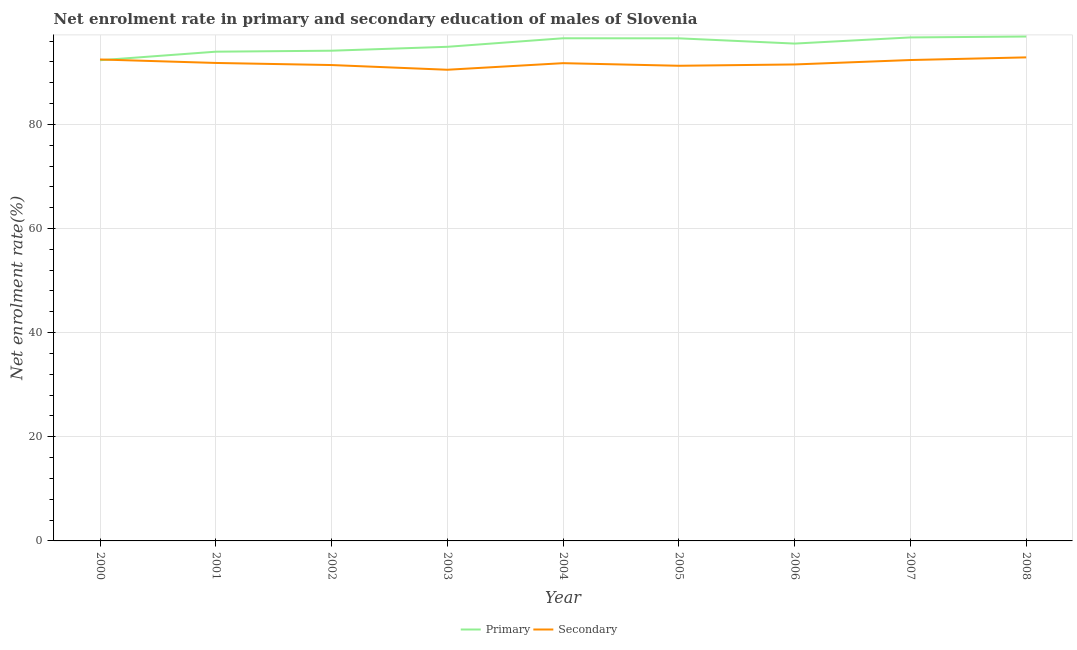How many different coloured lines are there?
Make the answer very short. 2. Does the line corresponding to enrollment rate in secondary education intersect with the line corresponding to enrollment rate in primary education?
Provide a short and direct response. Yes. What is the enrollment rate in primary education in 2008?
Give a very brief answer. 96.87. Across all years, what is the maximum enrollment rate in primary education?
Provide a short and direct response. 96.87. Across all years, what is the minimum enrollment rate in secondary education?
Keep it short and to the point. 90.49. In which year was the enrollment rate in primary education maximum?
Your answer should be compact. 2008. What is the total enrollment rate in primary education in the graph?
Give a very brief answer. 857.44. What is the difference between the enrollment rate in secondary education in 2002 and that in 2008?
Your answer should be very brief. -1.47. What is the difference between the enrollment rate in secondary education in 2002 and the enrollment rate in primary education in 2000?
Your answer should be compact. -0.92. What is the average enrollment rate in primary education per year?
Give a very brief answer. 95.27. In the year 2004, what is the difference between the enrollment rate in secondary education and enrollment rate in primary education?
Keep it short and to the point. -4.78. In how many years, is the enrollment rate in secondary education greater than 76 %?
Ensure brevity in your answer.  9. What is the ratio of the enrollment rate in secondary education in 2001 to that in 2004?
Provide a succinct answer. 1. What is the difference between the highest and the second highest enrollment rate in secondary education?
Make the answer very short. 0.4. What is the difference between the highest and the lowest enrollment rate in primary education?
Your response must be concise. 4.55. In how many years, is the enrollment rate in secondary education greater than the average enrollment rate in secondary education taken over all years?
Keep it short and to the point. 4. Is the enrollment rate in secondary education strictly greater than the enrollment rate in primary education over the years?
Your response must be concise. No. Is the enrollment rate in secondary education strictly less than the enrollment rate in primary education over the years?
Provide a short and direct response. No. How many years are there in the graph?
Your answer should be compact. 9. Does the graph contain grids?
Make the answer very short. Yes. How many legend labels are there?
Your answer should be very brief. 2. How are the legend labels stacked?
Provide a short and direct response. Horizontal. What is the title of the graph?
Your answer should be compact. Net enrolment rate in primary and secondary education of males of Slovenia. What is the label or title of the Y-axis?
Provide a succinct answer. Net enrolment rate(%). What is the Net enrolment rate(%) in Primary in 2000?
Provide a succinct answer. 92.31. What is the Net enrolment rate(%) in Secondary in 2000?
Keep it short and to the point. 92.46. What is the Net enrolment rate(%) in Primary in 2001?
Provide a short and direct response. 93.96. What is the Net enrolment rate(%) of Secondary in 2001?
Your answer should be compact. 91.79. What is the Net enrolment rate(%) in Primary in 2002?
Provide a short and direct response. 94.14. What is the Net enrolment rate(%) in Secondary in 2002?
Keep it short and to the point. 91.39. What is the Net enrolment rate(%) of Primary in 2003?
Ensure brevity in your answer.  94.89. What is the Net enrolment rate(%) of Secondary in 2003?
Offer a very short reply. 90.49. What is the Net enrolment rate(%) of Primary in 2004?
Your answer should be very brief. 96.53. What is the Net enrolment rate(%) in Secondary in 2004?
Offer a very short reply. 91.75. What is the Net enrolment rate(%) of Primary in 2005?
Keep it short and to the point. 96.52. What is the Net enrolment rate(%) in Secondary in 2005?
Offer a terse response. 91.25. What is the Net enrolment rate(%) in Primary in 2006?
Provide a succinct answer. 95.51. What is the Net enrolment rate(%) of Secondary in 2006?
Your response must be concise. 91.51. What is the Net enrolment rate(%) of Primary in 2007?
Your answer should be compact. 96.7. What is the Net enrolment rate(%) of Secondary in 2007?
Give a very brief answer. 92.35. What is the Net enrolment rate(%) of Primary in 2008?
Keep it short and to the point. 96.87. What is the Net enrolment rate(%) in Secondary in 2008?
Your answer should be compact. 92.86. Across all years, what is the maximum Net enrolment rate(%) of Primary?
Provide a succinct answer. 96.87. Across all years, what is the maximum Net enrolment rate(%) in Secondary?
Make the answer very short. 92.86. Across all years, what is the minimum Net enrolment rate(%) in Primary?
Your answer should be very brief. 92.31. Across all years, what is the minimum Net enrolment rate(%) of Secondary?
Offer a very short reply. 90.49. What is the total Net enrolment rate(%) in Primary in the graph?
Offer a very short reply. 857.44. What is the total Net enrolment rate(%) in Secondary in the graph?
Keep it short and to the point. 825.86. What is the difference between the Net enrolment rate(%) in Primary in 2000 and that in 2001?
Keep it short and to the point. -1.64. What is the difference between the Net enrolment rate(%) of Secondary in 2000 and that in 2001?
Your answer should be very brief. 0.67. What is the difference between the Net enrolment rate(%) in Primary in 2000 and that in 2002?
Your answer should be very brief. -1.83. What is the difference between the Net enrolment rate(%) in Secondary in 2000 and that in 2002?
Keep it short and to the point. 1.07. What is the difference between the Net enrolment rate(%) in Primary in 2000 and that in 2003?
Keep it short and to the point. -2.58. What is the difference between the Net enrolment rate(%) of Secondary in 2000 and that in 2003?
Provide a short and direct response. 1.98. What is the difference between the Net enrolment rate(%) in Primary in 2000 and that in 2004?
Keep it short and to the point. -4.22. What is the difference between the Net enrolment rate(%) in Secondary in 2000 and that in 2004?
Ensure brevity in your answer.  0.71. What is the difference between the Net enrolment rate(%) of Primary in 2000 and that in 2005?
Offer a very short reply. -4.21. What is the difference between the Net enrolment rate(%) in Secondary in 2000 and that in 2005?
Your answer should be compact. 1.21. What is the difference between the Net enrolment rate(%) in Primary in 2000 and that in 2006?
Give a very brief answer. -3.2. What is the difference between the Net enrolment rate(%) in Secondary in 2000 and that in 2006?
Offer a terse response. 0.96. What is the difference between the Net enrolment rate(%) of Primary in 2000 and that in 2007?
Your response must be concise. -4.38. What is the difference between the Net enrolment rate(%) in Secondary in 2000 and that in 2007?
Ensure brevity in your answer.  0.11. What is the difference between the Net enrolment rate(%) in Primary in 2000 and that in 2008?
Provide a succinct answer. -4.55. What is the difference between the Net enrolment rate(%) of Secondary in 2000 and that in 2008?
Offer a terse response. -0.4. What is the difference between the Net enrolment rate(%) of Primary in 2001 and that in 2002?
Give a very brief answer. -0.19. What is the difference between the Net enrolment rate(%) in Secondary in 2001 and that in 2002?
Your answer should be very brief. 0.4. What is the difference between the Net enrolment rate(%) of Primary in 2001 and that in 2003?
Your answer should be compact. -0.94. What is the difference between the Net enrolment rate(%) of Secondary in 2001 and that in 2003?
Provide a short and direct response. 1.31. What is the difference between the Net enrolment rate(%) in Primary in 2001 and that in 2004?
Offer a terse response. -2.58. What is the difference between the Net enrolment rate(%) in Secondary in 2001 and that in 2004?
Offer a terse response. 0.04. What is the difference between the Net enrolment rate(%) of Primary in 2001 and that in 2005?
Ensure brevity in your answer.  -2.57. What is the difference between the Net enrolment rate(%) in Secondary in 2001 and that in 2005?
Provide a short and direct response. 0.54. What is the difference between the Net enrolment rate(%) in Primary in 2001 and that in 2006?
Offer a terse response. -1.56. What is the difference between the Net enrolment rate(%) of Secondary in 2001 and that in 2006?
Provide a succinct answer. 0.29. What is the difference between the Net enrolment rate(%) in Primary in 2001 and that in 2007?
Provide a succinct answer. -2.74. What is the difference between the Net enrolment rate(%) of Secondary in 2001 and that in 2007?
Make the answer very short. -0.56. What is the difference between the Net enrolment rate(%) of Primary in 2001 and that in 2008?
Your answer should be very brief. -2.91. What is the difference between the Net enrolment rate(%) of Secondary in 2001 and that in 2008?
Make the answer very short. -1.07. What is the difference between the Net enrolment rate(%) in Primary in 2002 and that in 2003?
Provide a short and direct response. -0.75. What is the difference between the Net enrolment rate(%) in Secondary in 2002 and that in 2003?
Offer a very short reply. 0.9. What is the difference between the Net enrolment rate(%) of Primary in 2002 and that in 2004?
Offer a terse response. -2.39. What is the difference between the Net enrolment rate(%) in Secondary in 2002 and that in 2004?
Your answer should be compact. -0.36. What is the difference between the Net enrolment rate(%) of Primary in 2002 and that in 2005?
Provide a succinct answer. -2.38. What is the difference between the Net enrolment rate(%) of Secondary in 2002 and that in 2005?
Give a very brief answer. 0.14. What is the difference between the Net enrolment rate(%) in Primary in 2002 and that in 2006?
Your response must be concise. -1.37. What is the difference between the Net enrolment rate(%) of Secondary in 2002 and that in 2006?
Provide a short and direct response. -0.12. What is the difference between the Net enrolment rate(%) in Primary in 2002 and that in 2007?
Make the answer very short. -2.55. What is the difference between the Net enrolment rate(%) in Secondary in 2002 and that in 2007?
Your answer should be compact. -0.96. What is the difference between the Net enrolment rate(%) in Primary in 2002 and that in 2008?
Offer a very short reply. -2.72. What is the difference between the Net enrolment rate(%) in Secondary in 2002 and that in 2008?
Your answer should be compact. -1.47. What is the difference between the Net enrolment rate(%) of Primary in 2003 and that in 2004?
Make the answer very short. -1.64. What is the difference between the Net enrolment rate(%) of Secondary in 2003 and that in 2004?
Offer a terse response. -1.27. What is the difference between the Net enrolment rate(%) of Primary in 2003 and that in 2005?
Offer a terse response. -1.63. What is the difference between the Net enrolment rate(%) in Secondary in 2003 and that in 2005?
Offer a very short reply. -0.77. What is the difference between the Net enrolment rate(%) in Primary in 2003 and that in 2006?
Offer a very short reply. -0.62. What is the difference between the Net enrolment rate(%) in Secondary in 2003 and that in 2006?
Offer a very short reply. -1.02. What is the difference between the Net enrolment rate(%) in Primary in 2003 and that in 2007?
Provide a succinct answer. -1.8. What is the difference between the Net enrolment rate(%) of Secondary in 2003 and that in 2007?
Offer a terse response. -1.87. What is the difference between the Net enrolment rate(%) in Primary in 2003 and that in 2008?
Your response must be concise. -1.97. What is the difference between the Net enrolment rate(%) in Secondary in 2003 and that in 2008?
Your answer should be compact. -2.38. What is the difference between the Net enrolment rate(%) of Primary in 2004 and that in 2005?
Your answer should be compact. 0.01. What is the difference between the Net enrolment rate(%) of Secondary in 2004 and that in 2005?
Keep it short and to the point. 0.5. What is the difference between the Net enrolment rate(%) in Primary in 2004 and that in 2006?
Give a very brief answer. 1.02. What is the difference between the Net enrolment rate(%) in Secondary in 2004 and that in 2006?
Your answer should be compact. 0.25. What is the difference between the Net enrolment rate(%) of Primary in 2004 and that in 2007?
Your answer should be very brief. -0.16. What is the difference between the Net enrolment rate(%) in Secondary in 2004 and that in 2007?
Ensure brevity in your answer.  -0.6. What is the difference between the Net enrolment rate(%) of Primary in 2004 and that in 2008?
Give a very brief answer. -0.33. What is the difference between the Net enrolment rate(%) in Secondary in 2004 and that in 2008?
Provide a short and direct response. -1.11. What is the difference between the Net enrolment rate(%) of Primary in 2005 and that in 2006?
Provide a short and direct response. 1.01. What is the difference between the Net enrolment rate(%) in Secondary in 2005 and that in 2006?
Provide a succinct answer. -0.25. What is the difference between the Net enrolment rate(%) of Primary in 2005 and that in 2007?
Keep it short and to the point. -0.17. What is the difference between the Net enrolment rate(%) in Secondary in 2005 and that in 2007?
Make the answer very short. -1.1. What is the difference between the Net enrolment rate(%) in Primary in 2005 and that in 2008?
Your answer should be very brief. -0.34. What is the difference between the Net enrolment rate(%) in Secondary in 2005 and that in 2008?
Provide a short and direct response. -1.61. What is the difference between the Net enrolment rate(%) in Primary in 2006 and that in 2007?
Your response must be concise. -1.18. What is the difference between the Net enrolment rate(%) of Secondary in 2006 and that in 2007?
Make the answer very short. -0.85. What is the difference between the Net enrolment rate(%) in Primary in 2006 and that in 2008?
Provide a succinct answer. -1.35. What is the difference between the Net enrolment rate(%) in Secondary in 2006 and that in 2008?
Your answer should be compact. -1.36. What is the difference between the Net enrolment rate(%) of Primary in 2007 and that in 2008?
Your answer should be very brief. -0.17. What is the difference between the Net enrolment rate(%) in Secondary in 2007 and that in 2008?
Offer a very short reply. -0.51. What is the difference between the Net enrolment rate(%) of Primary in 2000 and the Net enrolment rate(%) of Secondary in 2001?
Your answer should be compact. 0.52. What is the difference between the Net enrolment rate(%) of Primary in 2000 and the Net enrolment rate(%) of Secondary in 2002?
Provide a short and direct response. 0.92. What is the difference between the Net enrolment rate(%) of Primary in 2000 and the Net enrolment rate(%) of Secondary in 2003?
Your answer should be compact. 1.83. What is the difference between the Net enrolment rate(%) in Primary in 2000 and the Net enrolment rate(%) in Secondary in 2004?
Offer a very short reply. 0.56. What is the difference between the Net enrolment rate(%) in Primary in 2000 and the Net enrolment rate(%) in Secondary in 2005?
Offer a very short reply. 1.06. What is the difference between the Net enrolment rate(%) in Primary in 2000 and the Net enrolment rate(%) in Secondary in 2006?
Your response must be concise. 0.81. What is the difference between the Net enrolment rate(%) of Primary in 2000 and the Net enrolment rate(%) of Secondary in 2007?
Your response must be concise. -0.04. What is the difference between the Net enrolment rate(%) of Primary in 2000 and the Net enrolment rate(%) of Secondary in 2008?
Provide a succinct answer. -0.55. What is the difference between the Net enrolment rate(%) in Primary in 2001 and the Net enrolment rate(%) in Secondary in 2002?
Ensure brevity in your answer.  2.56. What is the difference between the Net enrolment rate(%) in Primary in 2001 and the Net enrolment rate(%) in Secondary in 2003?
Provide a short and direct response. 3.47. What is the difference between the Net enrolment rate(%) of Primary in 2001 and the Net enrolment rate(%) of Secondary in 2004?
Keep it short and to the point. 2.2. What is the difference between the Net enrolment rate(%) of Primary in 2001 and the Net enrolment rate(%) of Secondary in 2005?
Offer a terse response. 2.7. What is the difference between the Net enrolment rate(%) in Primary in 2001 and the Net enrolment rate(%) in Secondary in 2006?
Offer a terse response. 2.45. What is the difference between the Net enrolment rate(%) of Primary in 2001 and the Net enrolment rate(%) of Secondary in 2007?
Ensure brevity in your answer.  1.6. What is the difference between the Net enrolment rate(%) in Primary in 2001 and the Net enrolment rate(%) in Secondary in 2008?
Keep it short and to the point. 1.09. What is the difference between the Net enrolment rate(%) of Primary in 2002 and the Net enrolment rate(%) of Secondary in 2003?
Your response must be concise. 3.66. What is the difference between the Net enrolment rate(%) in Primary in 2002 and the Net enrolment rate(%) in Secondary in 2004?
Your response must be concise. 2.39. What is the difference between the Net enrolment rate(%) of Primary in 2002 and the Net enrolment rate(%) of Secondary in 2005?
Provide a succinct answer. 2.89. What is the difference between the Net enrolment rate(%) of Primary in 2002 and the Net enrolment rate(%) of Secondary in 2006?
Provide a succinct answer. 2.64. What is the difference between the Net enrolment rate(%) in Primary in 2002 and the Net enrolment rate(%) in Secondary in 2007?
Provide a succinct answer. 1.79. What is the difference between the Net enrolment rate(%) of Primary in 2002 and the Net enrolment rate(%) of Secondary in 2008?
Keep it short and to the point. 1.28. What is the difference between the Net enrolment rate(%) of Primary in 2003 and the Net enrolment rate(%) of Secondary in 2004?
Provide a short and direct response. 3.14. What is the difference between the Net enrolment rate(%) in Primary in 2003 and the Net enrolment rate(%) in Secondary in 2005?
Your response must be concise. 3.64. What is the difference between the Net enrolment rate(%) in Primary in 2003 and the Net enrolment rate(%) in Secondary in 2006?
Your answer should be compact. 3.39. What is the difference between the Net enrolment rate(%) in Primary in 2003 and the Net enrolment rate(%) in Secondary in 2007?
Keep it short and to the point. 2.54. What is the difference between the Net enrolment rate(%) of Primary in 2003 and the Net enrolment rate(%) of Secondary in 2008?
Your answer should be compact. 2.03. What is the difference between the Net enrolment rate(%) in Primary in 2004 and the Net enrolment rate(%) in Secondary in 2005?
Offer a very short reply. 5.28. What is the difference between the Net enrolment rate(%) of Primary in 2004 and the Net enrolment rate(%) of Secondary in 2006?
Make the answer very short. 5.03. What is the difference between the Net enrolment rate(%) of Primary in 2004 and the Net enrolment rate(%) of Secondary in 2007?
Provide a short and direct response. 4.18. What is the difference between the Net enrolment rate(%) in Primary in 2004 and the Net enrolment rate(%) in Secondary in 2008?
Keep it short and to the point. 3.67. What is the difference between the Net enrolment rate(%) in Primary in 2005 and the Net enrolment rate(%) in Secondary in 2006?
Give a very brief answer. 5.02. What is the difference between the Net enrolment rate(%) of Primary in 2005 and the Net enrolment rate(%) of Secondary in 2007?
Offer a terse response. 4.17. What is the difference between the Net enrolment rate(%) in Primary in 2005 and the Net enrolment rate(%) in Secondary in 2008?
Your answer should be compact. 3.66. What is the difference between the Net enrolment rate(%) of Primary in 2006 and the Net enrolment rate(%) of Secondary in 2007?
Provide a short and direct response. 3.16. What is the difference between the Net enrolment rate(%) of Primary in 2006 and the Net enrolment rate(%) of Secondary in 2008?
Keep it short and to the point. 2.65. What is the difference between the Net enrolment rate(%) in Primary in 2007 and the Net enrolment rate(%) in Secondary in 2008?
Provide a short and direct response. 3.83. What is the average Net enrolment rate(%) of Primary per year?
Offer a very short reply. 95.27. What is the average Net enrolment rate(%) in Secondary per year?
Keep it short and to the point. 91.76. In the year 2000, what is the difference between the Net enrolment rate(%) in Primary and Net enrolment rate(%) in Secondary?
Your answer should be very brief. -0.15. In the year 2001, what is the difference between the Net enrolment rate(%) of Primary and Net enrolment rate(%) of Secondary?
Give a very brief answer. 2.16. In the year 2002, what is the difference between the Net enrolment rate(%) in Primary and Net enrolment rate(%) in Secondary?
Your answer should be very brief. 2.75. In the year 2003, what is the difference between the Net enrolment rate(%) in Primary and Net enrolment rate(%) in Secondary?
Ensure brevity in your answer.  4.41. In the year 2004, what is the difference between the Net enrolment rate(%) of Primary and Net enrolment rate(%) of Secondary?
Your answer should be compact. 4.78. In the year 2005, what is the difference between the Net enrolment rate(%) of Primary and Net enrolment rate(%) of Secondary?
Keep it short and to the point. 5.27. In the year 2006, what is the difference between the Net enrolment rate(%) in Primary and Net enrolment rate(%) in Secondary?
Ensure brevity in your answer.  4.01. In the year 2007, what is the difference between the Net enrolment rate(%) in Primary and Net enrolment rate(%) in Secondary?
Ensure brevity in your answer.  4.34. In the year 2008, what is the difference between the Net enrolment rate(%) in Primary and Net enrolment rate(%) in Secondary?
Provide a short and direct response. 4. What is the ratio of the Net enrolment rate(%) of Primary in 2000 to that in 2001?
Your answer should be very brief. 0.98. What is the ratio of the Net enrolment rate(%) of Secondary in 2000 to that in 2001?
Ensure brevity in your answer.  1.01. What is the ratio of the Net enrolment rate(%) of Primary in 2000 to that in 2002?
Make the answer very short. 0.98. What is the ratio of the Net enrolment rate(%) in Secondary in 2000 to that in 2002?
Your answer should be very brief. 1.01. What is the ratio of the Net enrolment rate(%) in Primary in 2000 to that in 2003?
Keep it short and to the point. 0.97. What is the ratio of the Net enrolment rate(%) in Secondary in 2000 to that in 2003?
Give a very brief answer. 1.02. What is the ratio of the Net enrolment rate(%) in Primary in 2000 to that in 2004?
Give a very brief answer. 0.96. What is the ratio of the Net enrolment rate(%) in Secondary in 2000 to that in 2004?
Offer a terse response. 1.01. What is the ratio of the Net enrolment rate(%) in Primary in 2000 to that in 2005?
Provide a short and direct response. 0.96. What is the ratio of the Net enrolment rate(%) in Secondary in 2000 to that in 2005?
Your response must be concise. 1.01. What is the ratio of the Net enrolment rate(%) in Primary in 2000 to that in 2006?
Your answer should be very brief. 0.97. What is the ratio of the Net enrolment rate(%) in Secondary in 2000 to that in 2006?
Offer a terse response. 1.01. What is the ratio of the Net enrolment rate(%) of Primary in 2000 to that in 2007?
Offer a terse response. 0.95. What is the ratio of the Net enrolment rate(%) of Secondary in 2000 to that in 2007?
Your response must be concise. 1. What is the ratio of the Net enrolment rate(%) in Primary in 2000 to that in 2008?
Ensure brevity in your answer.  0.95. What is the ratio of the Net enrolment rate(%) in Primary in 2001 to that in 2002?
Provide a succinct answer. 1. What is the ratio of the Net enrolment rate(%) of Secondary in 2001 to that in 2003?
Provide a short and direct response. 1.01. What is the ratio of the Net enrolment rate(%) of Primary in 2001 to that in 2004?
Offer a terse response. 0.97. What is the ratio of the Net enrolment rate(%) in Primary in 2001 to that in 2005?
Ensure brevity in your answer.  0.97. What is the ratio of the Net enrolment rate(%) in Secondary in 2001 to that in 2005?
Offer a terse response. 1.01. What is the ratio of the Net enrolment rate(%) in Primary in 2001 to that in 2006?
Provide a succinct answer. 0.98. What is the ratio of the Net enrolment rate(%) of Secondary in 2001 to that in 2006?
Offer a very short reply. 1. What is the ratio of the Net enrolment rate(%) in Primary in 2001 to that in 2007?
Your answer should be very brief. 0.97. What is the ratio of the Net enrolment rate(%) of Secondary in 2001 to that in 2007?
Ensure brevity in your answer.  0.99. What is the ratio of the Net enrolment rate(%) of Primary in 2002 to that in 2003?
Give a very brief answer. 0.99. What is the ratio of the Net enrolment rate(%) in Secondary in 2002 to that in 2003?
Give a very brief answer. 1.01. What is the ratio of the Net enrolment rate(%) of Primary in 2002 to that in 2004?
Provide a succinct answer. 0.98. What is the ratio of the Net enrolment rate(%) in Secondary in 2002 to that in 2004?
Give a very brief answer. 1. What is the ratio of the Net enrolment rate(%) of Primary in 2002 to that in 2005?
Provide a short and direct response. 0.98. What is the ratio of the Net enrolment rate(%) in Primary in 2002 to that in 2006?
Your answer should be very brief. 0.99. What is the ratio of the Net enrolment rate(%) of Primary in 2002 to that in 2007?
Your answer should be very brief. 0.97. What is the ratio of the Net enrolment rate(%) of Secondary in 2002 to that in 2007?
Ensure brevity in your answer.  0.99. What is the ratio of the Net enrolment rate(%) in Primary in 2002 to that in 2008?
Offer a very short reply. 0.97. What is the ratio of the Net enrolment rate(%) in Secondary in 2002 to that in 2008?
Provide a short and direct response. 0.98. What is the ratio of the Net enrolment rate(%) in Primary in 2003 to that in 2004?
Provide a succinct answer. 0.98. What is the ratio of the Net enrolment rate(%) of Secondary in 2003 to that in 2004?
Your answer should be compact. 0.99. What is the ratio of the Net enrolment rate(%) of Primary in 2003 to that in 2005?
Ensure brevity in your answer.  0.98. What is the ratio of the Net enrolment rate(%) of Secondary in 2003 to that in 2006?
Offer a terse response. 0.99. What is the ratio of the Net enrolment rate(%) of Primary in 2003 to that in 2007?
Your response must be concise. 0.98. What is the ratio of the Net enrolment rate(%) of Secondary in 2003 to that in 2007?
Provide a short and direct response. 0.98. What is the ratio of the Net enrolment rate(%) of Primary in 2003 to that in 2008?
Your answer should be very brief. 0.98. What is the ratio of the Net enrolment rate(%) of Secondary in 2003 to that in 2008?
Keep it short and to the point. 0.97. What is the ratio of the Net enrolment rate(%) of Secondary in 2004 to that in 2005?
Provide a succinct answer. 1.01. What is the ratio of the Net enrolment rate(%) of Primary in 2004 to that in 2006?
Ensure brevity in your answer.  1.01. What is the ratio of the Net enrolment rate(%) of Secondary in 2004 to that in 2006?
Ensure brevity in your answer.  1. What is the ratio of the Net enrolment rate(%) of Secondary in 2004 to that in 2007?
Make the answer very short. 0.99. What is the ratio of the Net enrolment rate(%) in Secondary in 2004 to that in 2008?
Provide a short and direct response. 0.99. What is the ratio of the Net enrolment rate(%) in Primary in 2005 to that in 2006?
Offer a terse response. 1.01. What is the ratio of the Net enrolment rate(%) in Primary in 2005 to that in 2007?
Ensure brevity in your answer.  1. What is the ratio of the Net enrolment rate(%) of Secondary in 2005 to that in 2007?
Give a very brief answer. 0.99. What is the ratio of the Net enrolment rate(%) in Secondary in 2005 to that in 2008?
Your answer should be very brief. 0.98. What is the ratio of the Net enrolment rate(%) in Primary in 2006 to that in 2007?
Keep it short and to the point. 0.99. What is the ratio of the Net enrolment rate(%) in Primary in 2006 to that in 2008?
Your response must be concise. 0.99. What is the ratio of the Net enrolment rate(%) of Secondary in 2006 to that in 2008?
Give a very brief answer. 0.99. What is the ratio of the Net enrolment rate(%) of Secondary in 2007 to that in 2008?
Make the answer very short. 0.99. What is the difference between the highest and the second highest Net enrolment rate(%) of Primary?
Provide a succinct answer. 0.17. What is the difference between the highest and the second highest Net enrolment rate(%) in Secondary?
Provide a short and direct response. 0.4. What is the difference between the highest and the lowest Net enrolment rate(%) in Primary?
Provide a short and direct response. 4.55. What is the difference between the highest and the lowest Net enrolment rate(%) of Secondary?
Your answer should be compact. 2.38. 